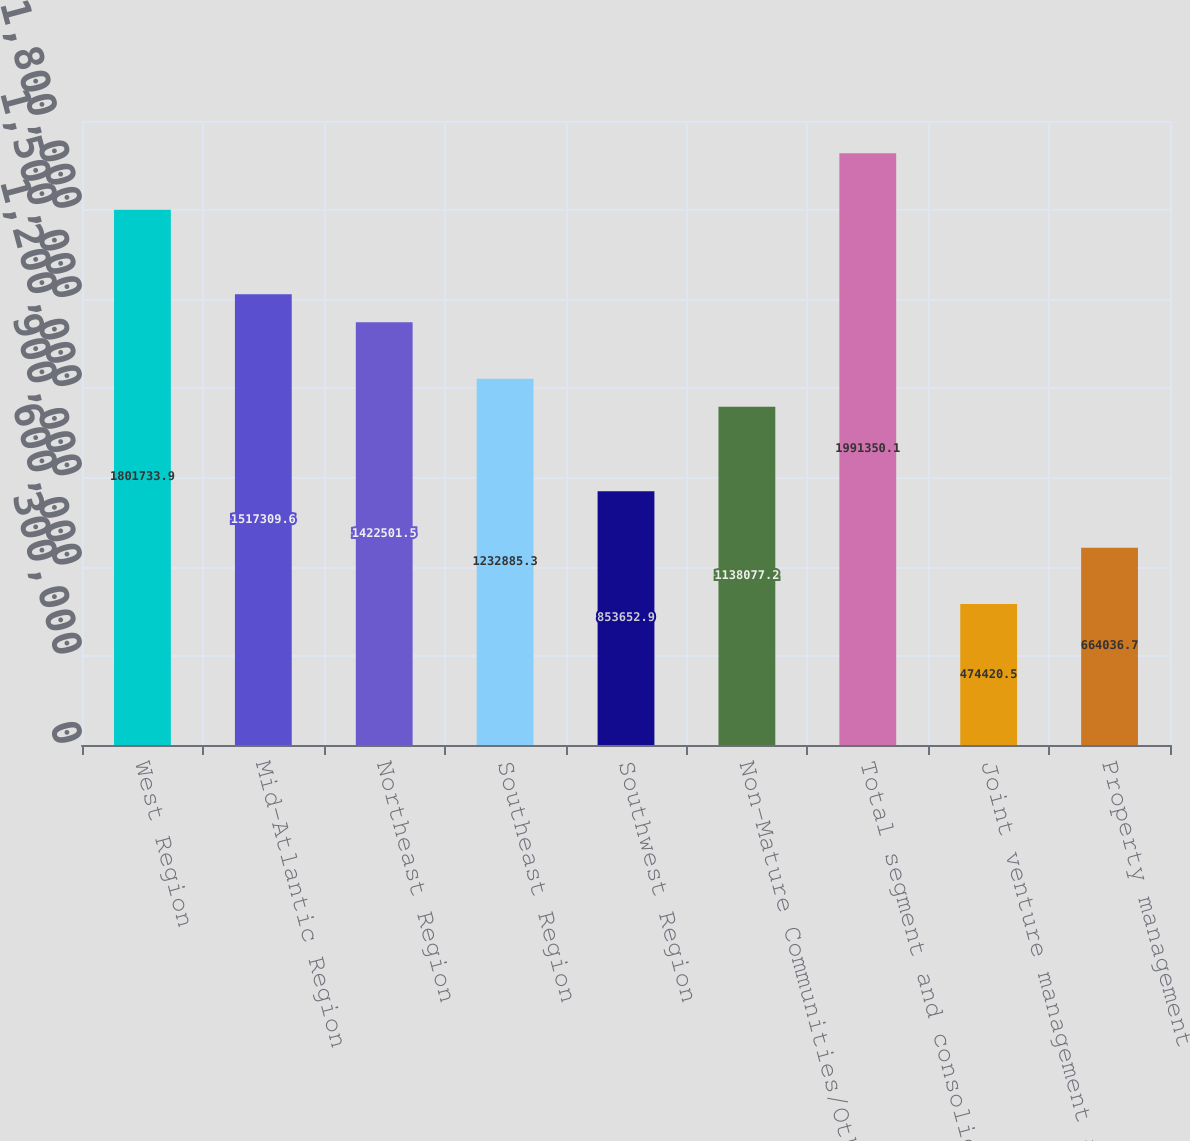Convert chart. <chart><loc_0><loc_0><loc_500><loc_500><bar_chart><fcel>West Region<fcel>Mid-Atlantic Region<fcel>Northeast Region<fcel>Southeast Region<fcel>Southwest Region<fcel>Non-Mature Communities/Other<fcel>Total segment and consolidated<fcel>Joint venture management and<fcel>Property management<nl><fcel>1.80173e+06<fcel>1.51731e+06<fcel>1.4225e+06<fcel>1.23289e+06<fcel>853653<fcel>1.13808e+06<fcel>1.99135e+06<fcel>474420<fcel>664037<nl></chart> 